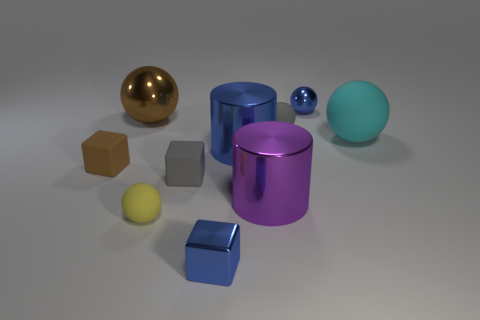Subtract all tiny matte blocks. How many blocks are left? 1 Subtract all cyan balls. How many balls are left? 4 Subtract all purple balls. Subtract all red blocks. How many balls are left? 5 Subtract all cylinders. How many objects are left? 8 Subtract all cyan matte objects. Subtract all cylinders. How many objects are left? 7 Add 8 yellow things. How many yellow things are left? 9 Add 4 brown metal balls. How many brown metal balls exist? 5 Subtract 0 yellow cylinders. How many objects are left? 10 